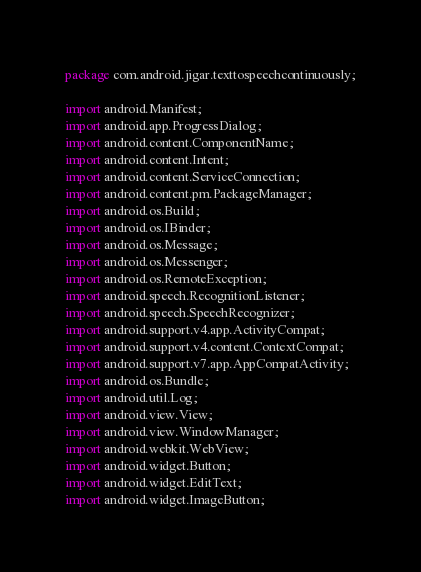<code> <loc_0><loc_0><loc_500><loc_500><_Java_>package com.android.jigar.texttospeechcontinuously;

import android.Manifest;
import android.app.ProgressDialog;
import android.content.ComponentName;
import android.content.Intent;
import android.content.ServiceConnection;
import android.content.pm.PackageManager;
import android.os.Build;
import android.os.IBinder;
import android.os.Message;
import android.os.Messenger;
import android.os.RemoteException;
import android.speech.RecognitionListener;
import android.speech.SpeechRecognizer;
import android.support.v4.app.ActivityCompat;
import android.support.v4.content.ContextCompat;
import android.support.v7.app.AppCompatActivity;
import android.os.Bundle;
import android.util.Log;
import android.view.View;
import android.view.WindowManager;
import android.webkit.WebView;
import android.widget.Button;
import android.widget.EditText;
import android.widget.ImageButton;</code> 